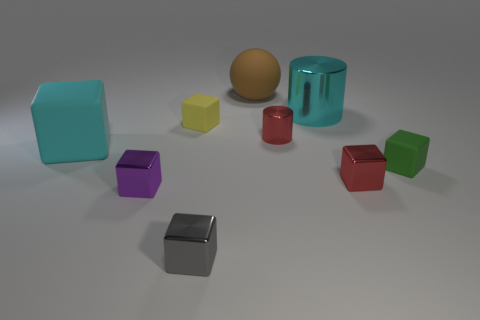Subtract 2 cubes. How many cubes are left? 4 Subtract all small gray cubes. How many cubes are left? 5 Subtract all purple blocks. How many blocks are left? 5 Subtract all blue cubes. Subtract all cyan cylinders. How many cubes are left? 6 Subtract all spheres. How many objects are left? 8 Add 8 big cylinders. How many big cylinders are left? 9 Add 8 large cylinders. How many large cylinders exist? 9 Subtract 0 blue cylinders. How many objects are left? 9 Subtract all tiny metallic blocks. Subtract all red shiny blocks. How many objects are left? 5 